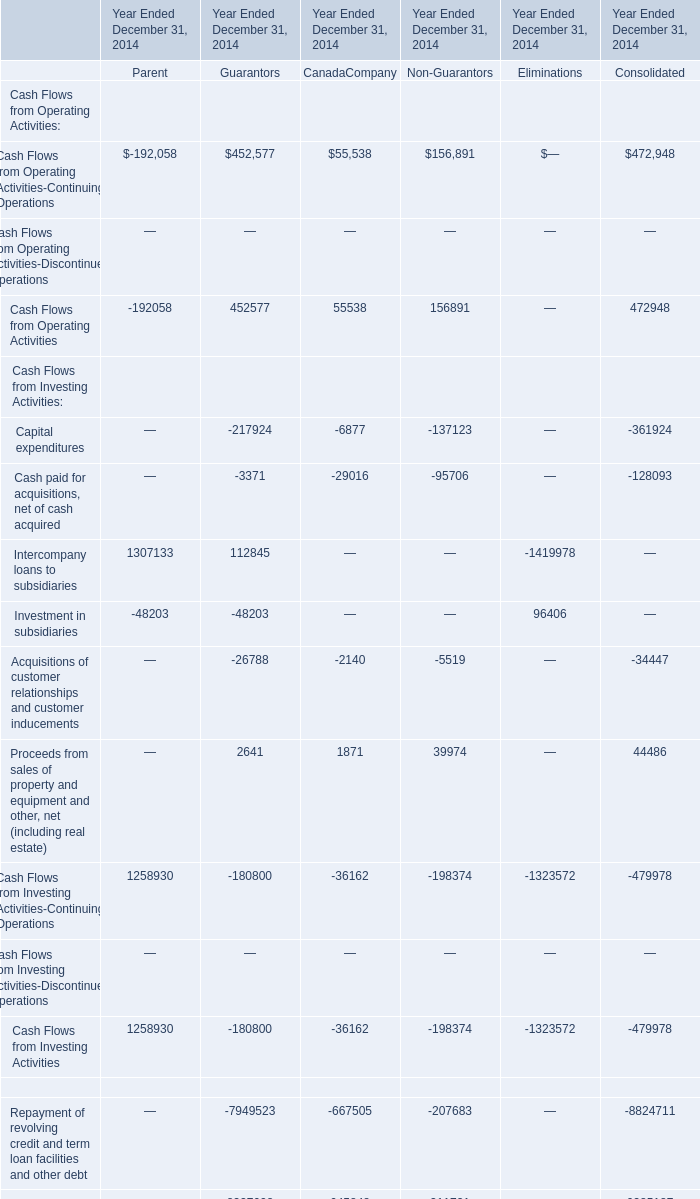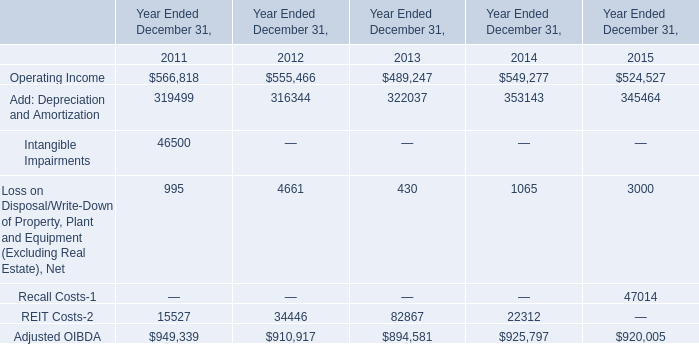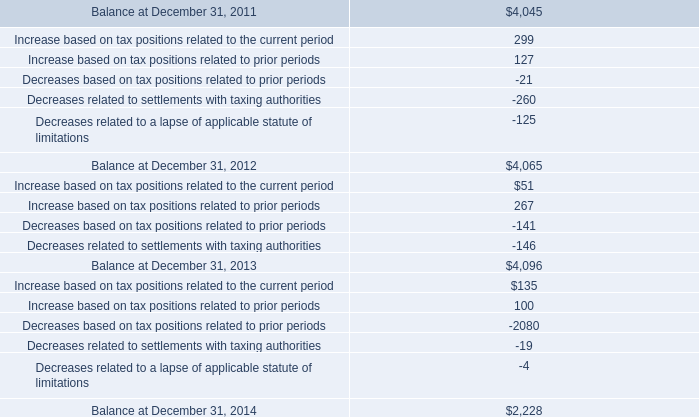for us federal purposes , how many years are currently involved in irs controversies? 
Computations: (2008 - 1999)
Answer: 9.0. accrued interest represented how much of the ending balance in uncertain tax benefits as of december 31 , 2014? 
Computations: (258 / 2228)
Answer: 0.1158. 